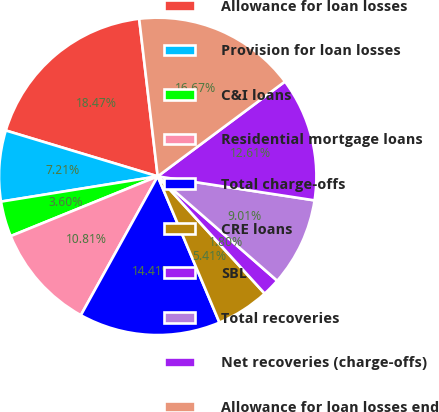Convert chart. <chart><loc_0><loc_0><loc_500><loc_500><pie_chart><fcel>Allowance for loan losses<fcel>Provision for loan losses<fcel>C&I loans<fcel>Residential mortgage loans<fcel>Total charge-offs<fcel>CRE loans<fcel>SBL<fcel>Total recoveries<fcel>Net recoveries (charge-offs)<fcel>Allowance for loan losses end<nl><fcel>18.47%<fcel>7.21%<fcel>3.6%<fcel>10.81%<fcel>14.41%<fcel>5.41%<fcel>1.8%<fcel>9.01%<fcel>12.61%<fcel>16.67%<nl></chart> 